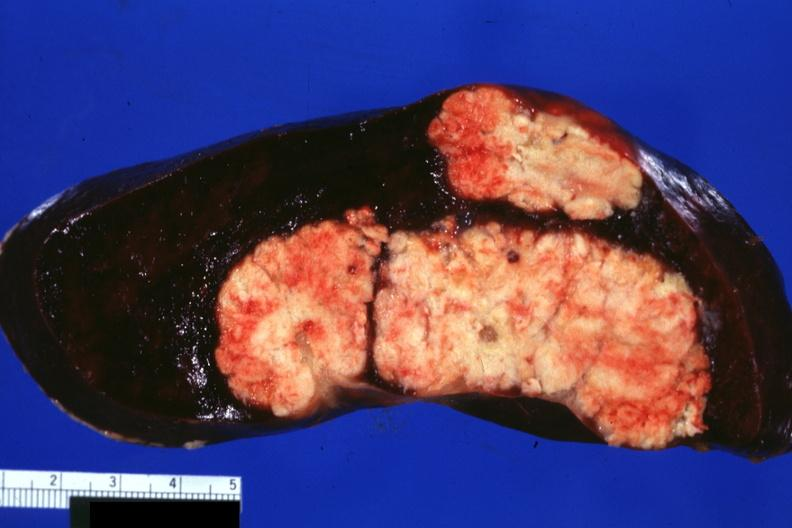s notochord present?
Answer the question using a single word or phrase. No 